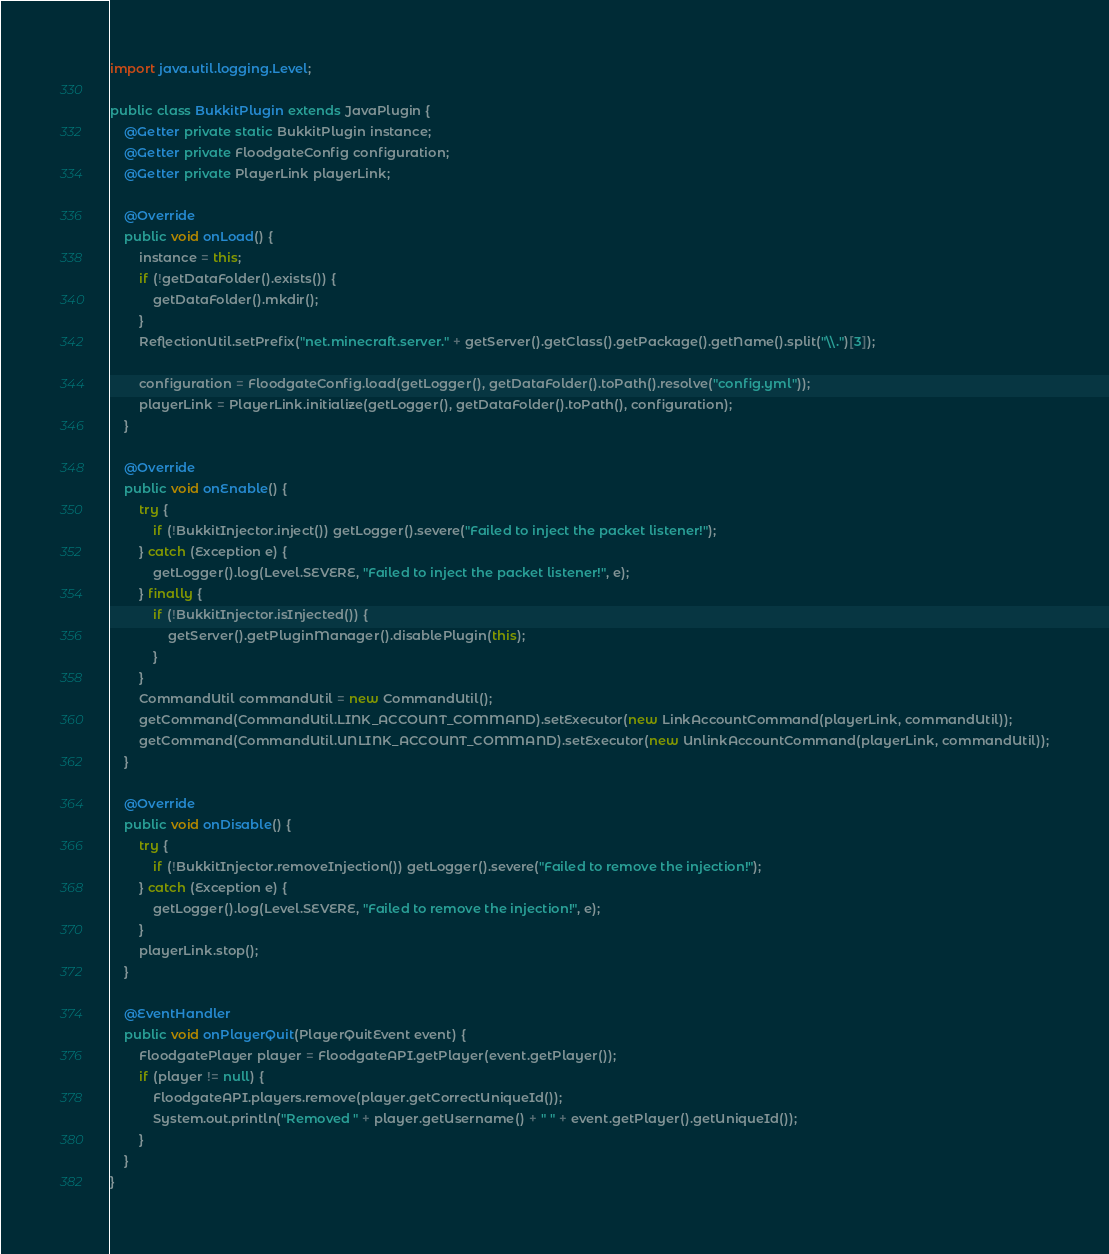Convert code to text. <code><loc_0><loc_0><loc_500><loc_500><_Java_>
import java.util.logging.Level;

public class BukkitPlugin extends JavaPlugin {
    @Getter private static BukkitPlugin instance;
    @Getter private FloodgateConfig configuration;
    @Getter private PlayerLink playerLink;

    @Override
    public void onLoad() {
        instance = this;
        if (!getDataFolder().exists()) {
            getDataFolder().mkdir();
        }
        ReflectionUtil.setPrefix("net.minecraft.server." + getServer().getClass().getPackage().getName().split("\\.")[3]);

        configuration = FloodgateConfig.load(getLogger(), getDataFolder().toPath().resolve("config.yml"));
        playerLink = PlayerLink.initialize(getLogger(), getDataFolder().toPath(), configuration);
    }

    @Override
    public void onEnable() {
        try {
            if (!BukkitInjector.inject()) getLogger().severe("Failed to inject the packet listener!");
        } catch (Exception e) {
            getLogger().log(Level.SEVERE, "Failed to inject the packet listener!", e);
        } finally {
            if (!BukkitInjector.isInjected()) {
                getServer().getPluginManager().disablePlugin(this);
            }
        }
        CommandUtil commandUtil = new CommandUtil();
        getCommand(CommandUtil.LINK_ACCOUNT_COMMAND).setExecutor(new LinkAccountCommand(playerLink, commandUtil));
        getCommand(CommandUtil.UNLINK_ACCOUNT_COMMAND).setExecutor(new UnlinkAccountCommand(playerLink, commandUtil));
    }

    @Override
    public void onDisable() {
        try {
            if (!BukkitInjector.removeInjection()) getLogger().severe("Failed to remove the injection!");
        } catch (Exception e) {
            getLogger().log(Level.SEVERE, "Failed to remove the injection!", e);
        }
        playerLink.stop();
    }

    @EventHandler
    public void onPlayerQuit(PlayerQuitEvent event) {
        FloodgatePlayer player = FloodgateAPI.getPlayer(event.getPlayer());
        if (player != null) {
            FloodgateAPI.players.remove(player.getCorrectUniqueId());
            System.out.println("Removed " + player.getUsername() + " " + event.getPlayer().getUniqueId());
        }
    }
}
</code> 